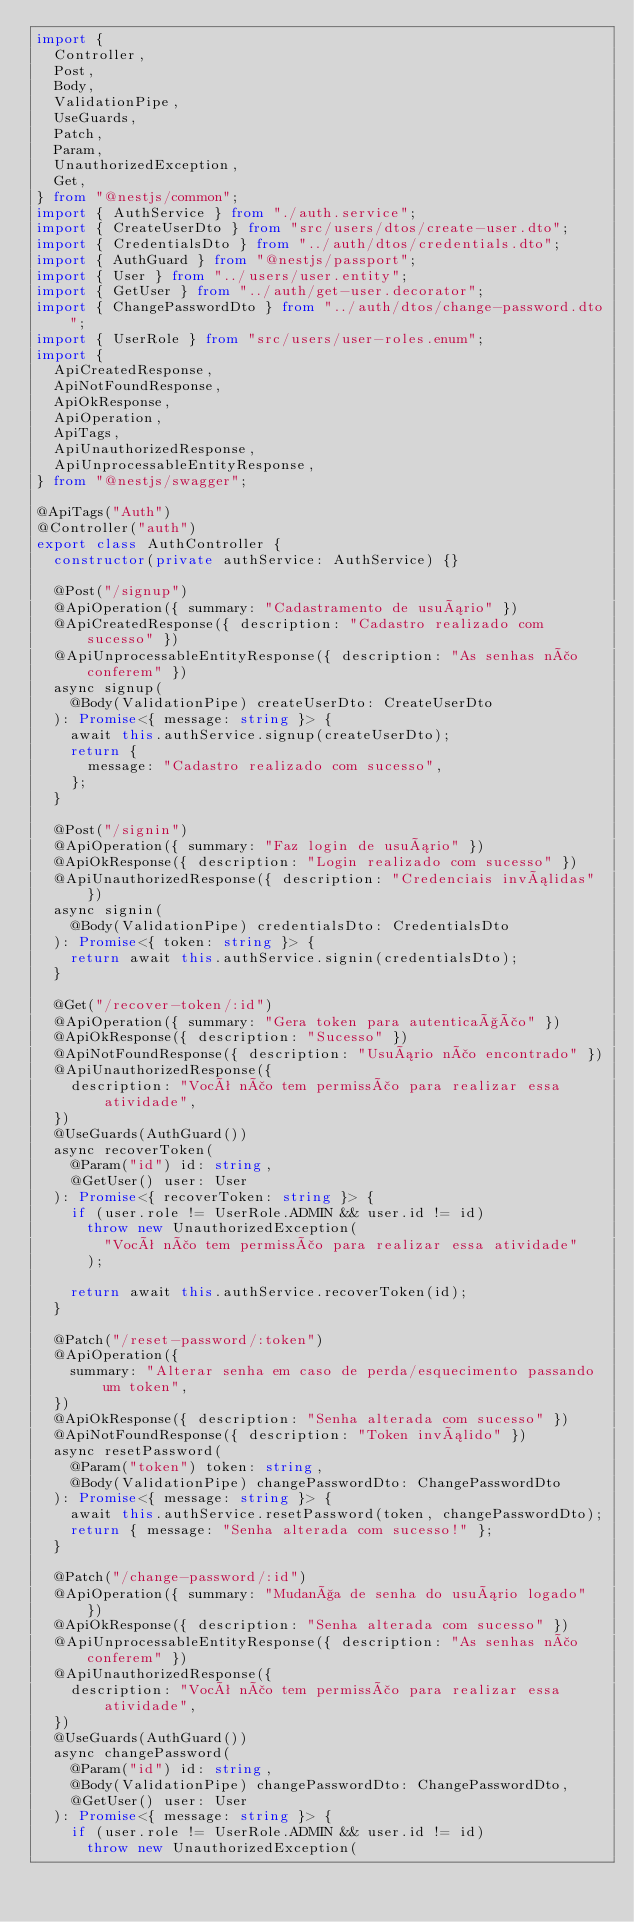Convert code to text. <code><loc_0><loc_0><loc_500><loc_500><_TypeScript_>import {
  Controller,
  Post,
  Body,
  ValidationPipe,
  UseGuards,
  Patch,
  Param,
  UnauthorizedException,
  Get,
} from "@nestjs/common";
import { AuthService } from "./auth.service";
import { CreateUserDto } from "src/users/dtos/create-user.dto";
import { CredentialsDto } from "../auth/dtos/credentials.dto";
import { AuthGuard } from "@nestjs/passport";
import { User } from "../users/user.entity";
import { GetUser } from "../auth/get-user.decorator";
import { ChangePasswordDto } from "../auth/dtos/change-password.dto";
import { UserRole } from "src/users/user-roles.enum";
import {
  ApiCreatedResponse,
  ApiNotFoundResponse,
  ApiOkResponse,
  ApiOperation,
  ApiTags,
  ApiUnauthorizedResponse,
  ApiUnprocessableEntityResponse,
} from "@nestjs/swagger";

@ApiTags("Auth")
@Controller("auth")
export class AuthController {
  constructor(private authService: AuthService) {}

  @Post("/signup")
  @ApiOperation({ summary: "Cadastramento de usuário" })
  @ApiCreatedResponse({ description: "Cadastro realizado com sucesso" })
  @ApiUnprocessableEntityResponse({ description: "As senhas não conferem" })
  async signup(
    @Body(ValidationPipe) createUserDto: CreateUserDto
  ): Promise<{ message: string }> {
    await this.authService.signup(createUserDto);
    return {
      message: "Cadastro realizado com sucesso",
    };
  }

  @Post("/signin")
  @ApiOperation({ summary: "Faz login de usuário" })
  @ApiOkResponse({ description: "Login realizado com sucesso" })
  @ApiUnauthorizedResponse({ description: "Credenciais inválidas" })
  async signin(
    @Body(ValidationPipe) credentialsDto: CredentialsDto
  ): Promise<{ token: string }> {
    return await this.authService.signin(credentialsDto);
  }

  @Get("/recover-token/:id")
  @ApiOperation({ summary: "Gera token para autenticação" })
  @ApiOkResponse({ description: "Sucesso" })
  @ApiNotFoundResponse({ description: "Usuário não encontrado" })
  @ApiUnauthorizedResponse({
    description: "Você não tem permissão para realizar essa atividade",
  })
  @UseGuards(AuthGuard())
  async recoverToken(
    @Param("id") id: string,
    @GetUser() user: User
  ): Promise<{ recoverToken: string }> {
    if (user.role != UserRole.ADMIN && user.id != id)
      throw new UnauthorizedException(
        "Você não tem permissão para realizar essa atividade"
      );

    return await this.authService.recoverToken(id);
  }

  @Patch("/reset-password/:token")
  @ApiOperation({
    summary: "Alterar senha em caso de perda/esquecimento passando um token",
  })
  @ApiOkResponse({ description: "Senha alterada com sucesso" })
  @ApiNotFoundResponse({ description: "Token inválido" })
  async resetPassword(
    @Param("token") token: string,
    @Body(ValidationPipe) changePasswordDto: ChangePasswordDto
  ): Promise<{ message: string }> {
    await this.authService.resetPassword(token, changePasswordDto);
    return { message: "Senha alterada com sucesso!" };
  }

  @Patch("/change-password/:id")
  @ApiOperation({ summary: "Mudança de senha do usuário logado" })
  @ApiOkResponse({ description: "Senha alterada com sucesso" })
  @ApiUnprocessableEntityResponse({ description: "As senhas não conferem" })
  @ApiUnauthorizedResponse({
    description: "Você não tem permissão para realizar essa atividade",
  })
  @UseGuards(AuthGuard())
  async changePassword(
    @Param("id") id: string,
    @Body(ValidationPipe) changePasswordDto: ChangePasswordDto,
    @GetUser() user: User
  ): Promise<{ message: string }> {
    if (user.role != UserRole.ADMIN && user.id != id)
      throw new UnauthorizedException(</code> 